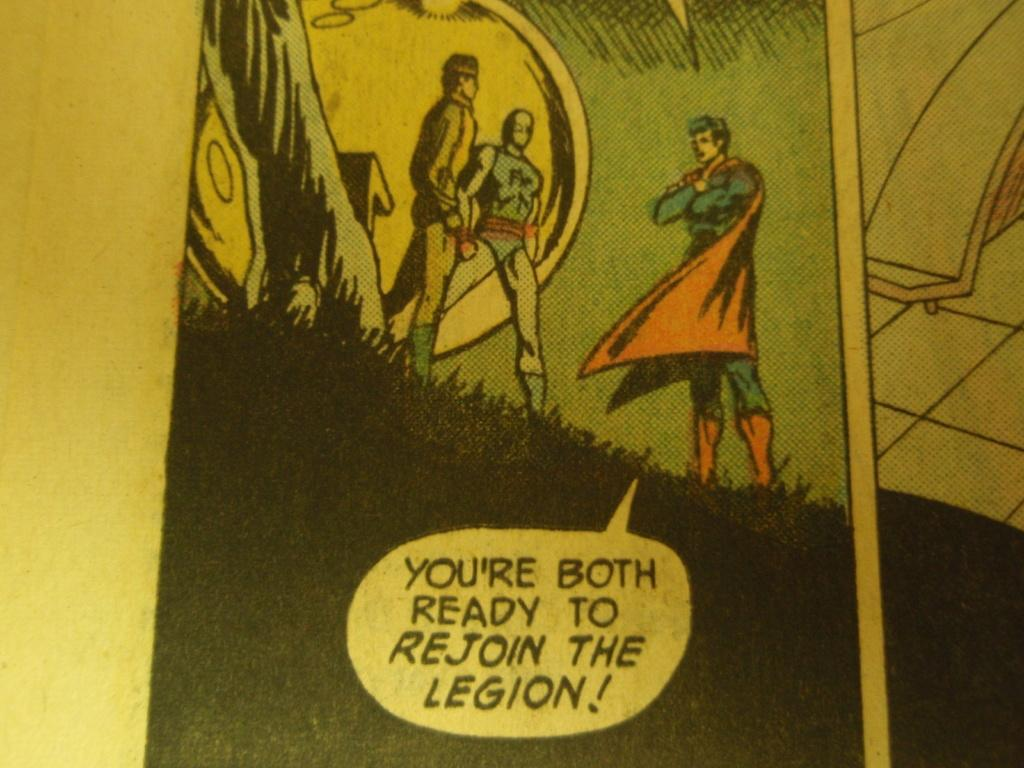Provide a one-sentence caption for the provided image. A superman comic where superman asks if others are ready to join. 